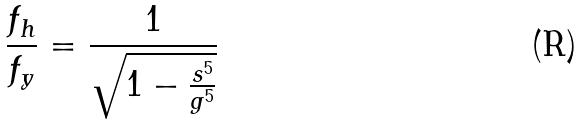<formula> <loc_0><loc_0><loc_500><loc_500>\frac { f _ { h } } { f _ { y } } = \frac { 1 } { \sqrt { 1 - \frac { s ^ { 5 } } { g ^ { 5 } } } }</formula> 